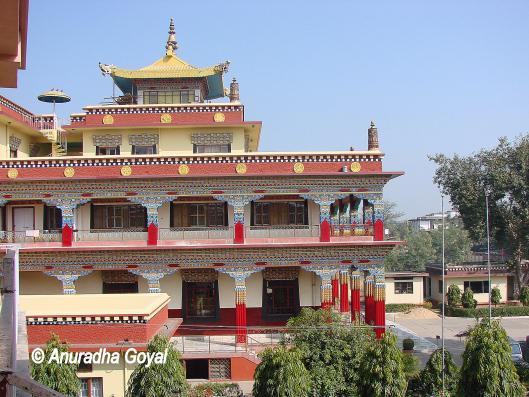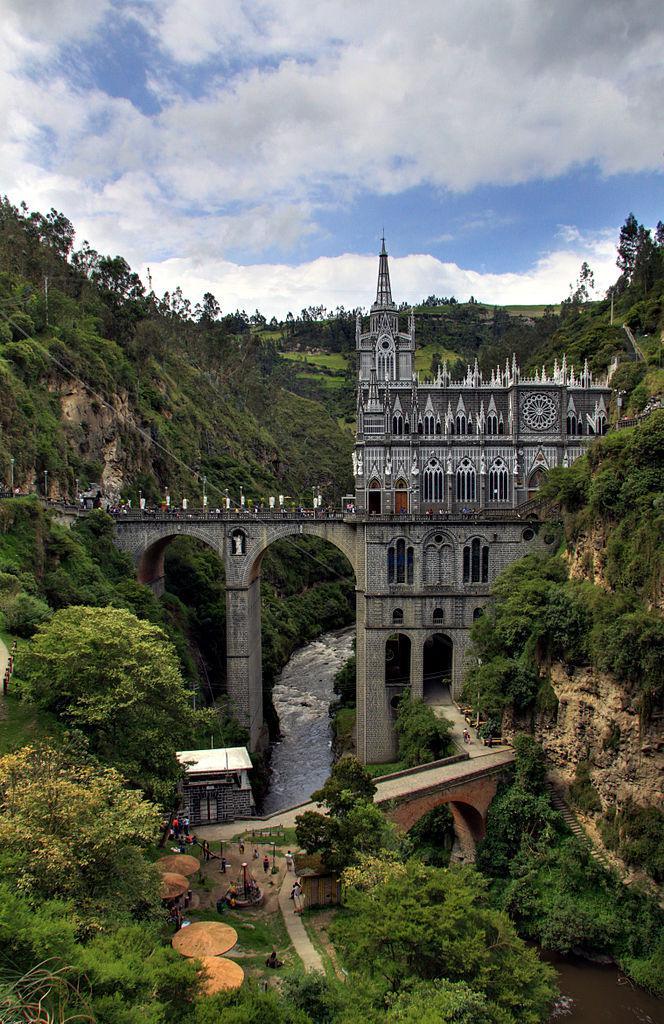The first image is the image on the left, the second image is the image on the right. Examine the images to the left and right. Is the description "At least one flag is waving at the site of one building." accurate? Answer yes or no. No. 